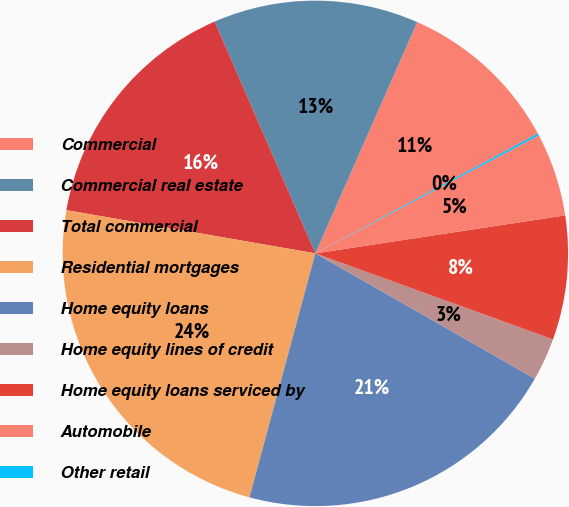Convert chart. <chart><loc_0><loc_0><loc_500><loc_500><pie_chart><fcel>Commercial<fcel>Commercial real estate<fcel>Total commercial<fcel>Residential mortgages<fcel>Home equity loans<fcel>Home equity lines of credit<fcel>Home equity loans serviced by<fcel>Automobile<fcel>Other retail<nl><fcel>10.53%<fcel>13.13%<fcel>15.74%<fcel>23.54%<fcel>20.94%<fcel>2.73%<fcel>7.93%<fcel>5.33%<fcel>0.13%<nl></chart> 